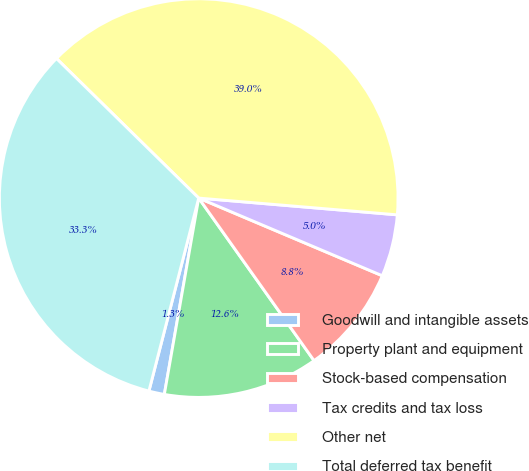Convert chart to OTSL. <chart><loc_0><loc_0><loc_500><loc_500><pie_chart><fcel>Goodwill and intangible assets<fcel>Property plant and equipment<fcel>Stock-based compensation<fcel>Tax credits and tax loss<fcel>Other net<fcel>Total deferred tax benefit<nl><fcel>1.26%<fcel>12.58%<fcel>8.81%<fcel>5.03%<fcel>38.99%<fcel>33.33%<nl></chart> 